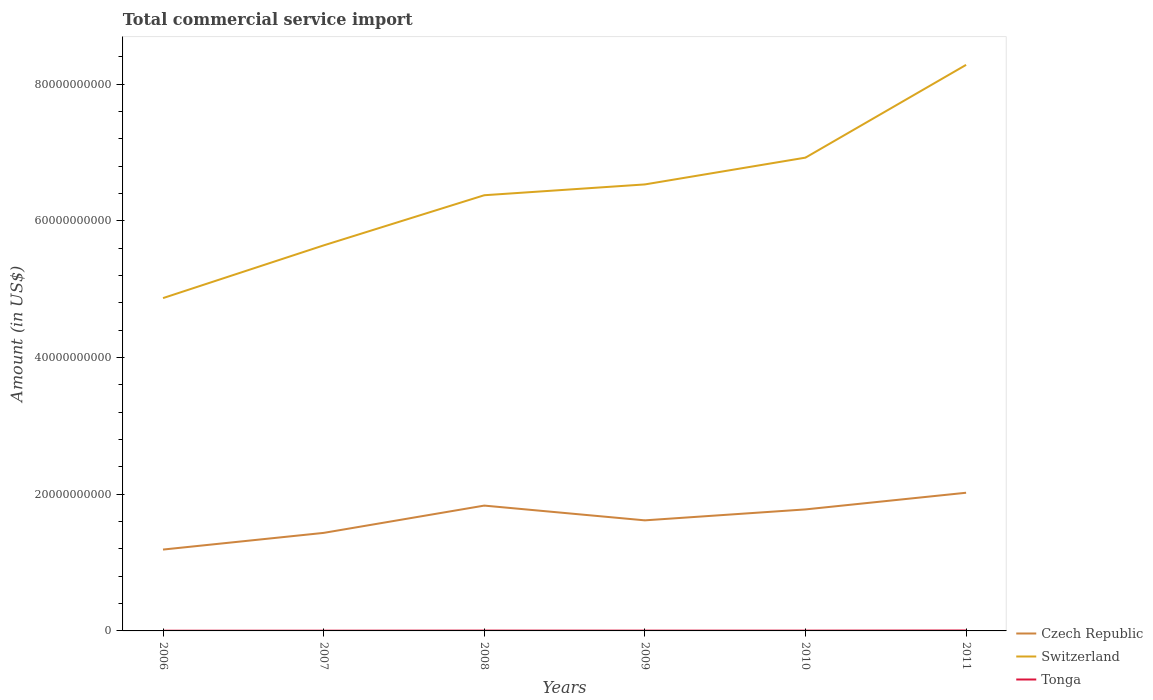Does the line corresponding to Switzerland intersect with the line corresponding to Tonga?
Provide a short and direct response. No. Across all years, what is the maximum total commercial service import in Switzerland?
Give a very brief answer. 4.87e+1. In which year was the total commercial service import in Switzerland maximum?
Provide a short and direct response. 2006. What is the total total commercial service import in Czech Republic in the graph?
Offer a very short reply. -5.87e+09. What is the difference between the highest and the second highest total commercial service import in Switzerland?
Your response must be concise. 3.41e+1. What is the difference between the highest and the lowest total commercial service import in Czech Republic?
Make the answer very short. 3. How many lines are there?
Give a very brief answer. 3. How many years are there in the graph?
Offer a very short reply. 6. What is the difference between two consecutive major ticks on the Y-axis?
Your response must be concise. 2.00e+1. Where does the legend appear in the graph?
Make the answer very short. Bottom right. What is the title of the graph?
Make the answer very short. Total commercial service import. Does "Congo (Republic)" appear as one of the legend labels in the graph?
Offer a terse response. No. What is the label or title of the X-axis?
Make the answer very short. Years. What is the label or title of the Y-axis?
Keep it short and to the point. Amount (in US$). What is the Amount (in US$) in Czech Republic in 2006?
Your answer should be compact. 1.19e+1. What is the Amount (in US$) in Switzerland in 2006?
Your answer should be very brief. 4.87e+1. What is the Amount (in US$) of Tonga in 2006?
Offer a terse response. 2.95e+07. What is the Amount (in US$) of Czech Republic in 2007?
Offer a very short reply. 1.43e+1. What is the Amount (in US$) of Switzerland in 2007?
Ensure brevity in your answer.  5.64e+1. What is the Amount (in US$) in Tonga in 2007?
Your answer should be very brief. 3.50e+07. What is the Amount (in US$) of Czech Republic in 2008?
Your answer should be very brief. 1.83e+1. What is the Amount (in US$) of Switzerland in 2008?
Your answer should be very brief. 6.37e+1. What is the Amount (in US$) in Tonga in 2008?
Provide a short and direct response. 4.82e+07. What is the Amount (in US$) of Czech Republic in 2009?
Keep it short and to the point. 1.62e+1. What is the Amount (in US$) of Switzerland in 2009?
Your answer should be compact. 6.53e+1. What is the Amount (in US$) of Tonga in 2009?
Your answer should be compact. 4.43e+07. What is the Amount (in US$) of Czech Republic in 2010?
Ensure brevity in your answer.  1.78e+1. What is the Amount (in US$) in Switzerland in 2010?
Offer a terse response. 6.92e+1. What is the Amount (in US$) of Tonga in 2010?
Your answer should be compact. 4.24e+07. What is the Amount (in US$) in Czech Republic in 2011?
Give a very brief answer. 2.02e+1. What is the Amount (in US$) in Switzerland in 2011?
Your response must be concise. 8.28e+1. What is the Amount (in US$) in Tonga in 2011?
Give a very brief answer. 6.34e+07. Across all years, what is the maximum Amount (in US$) in Czech Republic?
Provide a short and direct response. 2.02e+1. Across all years, what is the maximum Amount (in US$) in Switzerland?
Provide a short and direct response. 8.28e+1. Across all years, what is the maximum Amount (in US$) in Tonga?
Your answer should be very brief. 6.34e+07. Across all years, what is the minimum Amount (in US$) in Czech Republic?
Make the answer very short. 1.19e+1. Across all years, what is the minimum Amount (in US$) of Switzerland?
Keep it short and to the point. 4.87e+1. Across all years, what is the minimum Amount (in US$) of Tonga?
Offer a very short reply. 2.95e+07. What is the total Amount (in US$) of Czech Republic in the graph?
Your answer should be very brief. 9.87e+1. What is the total Amount (in US$) in Switzerland in the graph?
Keep it short and to the point. 3.86e+11. What is the total Amount (in US$) in Tonga in the graph?
Ensure brevity in your answer.  2.63e+08. What is the difference between the Amount (in US$) in Czech Republic in 2006 and that in 2007?
Offer a very short reply. -2.44e+09. What is the difference between the Amount (in US$) in Switzerland in 2006 and that in 2007?
Make the answer very short. -7.71e+09. What is the difference between the Amount (in US$) of Tonga in 2006 and that in 2007?
Offer a very short reply. -5.45e+06. What is the difference between the Amount (in US$) in Czech Republic in 2006 and that in 2008?
Your response must be concise. -6.43e+09. What is the difference between the Amount (in US$) in Switzerland in 2006 and that in 2008?
Provide a short and direct response. -1.50e+1. What is the difference between the Amount (in US$) in Tonga in 2006 and that in 2008?
Give a very brief answer. -1.87e+07. What is the difference between the Amount (in US$) in Czech Republic in 2006 and that in 2009?
Your answer should be very brief. -4.27e+09. What is the difference between the Amount (in US$) in Switzerland in 2006 and that in 2009?
Give a very brief answer. -1.66e+1. What is the difference between the Amount (in US$) in Tonga in 2006 and that in 2009?
Provide a short and direct response. -1.48e+07. What is the difference between the Amount (in US$) in Czech Republic in 2006 and that in 2010?
Offer a very short reply. -5.87e+09. What is the difference between the Amount (in US$) of Switzerland in 2006 and that in 2010?
Make the answer very short. -2.05e+1. What is the difference between the Amount (in US$) of Tonga in 2006 and that in 2010?
Provide a succinct answer. -1.29e+07. What is the difference between the Amount (in US$) in Czech Republic in 2006 and that in 2011?
Offer a very short reply. -8.31e+09. What is the difference between the Amount (in US$) in Switzerland in 2006 and that in 2011?
Offer a very short reply. -3.41e+1. What is the difference between the Amount (in US$) in Tonga in 2006 and that in 2011?
Offer a very short reply. -3.39e+07. What is the difference between the Amount (in US$) of Czech Republic in 2007 and that in 2008?
Provide a short and direct response. -3.99e+09. What is the difference between the Amount (in US$) of Switzerland in 2007 and that in 2008?
Offer a very short reply. -7.34e+09. What is the difference between the Amount (in US$) in Tonga in 2007 and that in 2008?
Give a very brief answer. -1.33e+07. What is the difference between the Amount (in US$) of Czech Republic in 2007 and that in 2009?
Ensure brevity in your answer.  -1.83e+09. What is the difference between the Amount (in US$) in Switzerland in 2007 and that in 2009?
Your answer should be very brief. -8.92e+09. What is the difference between the Amount (in US$) of Tonga in 2007 and that in 2009?
Keep it short and to the point. -9.30e+06. What is the difference between the Amount (in US$) in Czech Republic in 2007 and that in 2010?
Your response must be concise. -3.43e+09. What is the difference between the Amount (in US$) of Switzerland in 2007 and that in 2010?
Provide a short and direct response. -1.28e+1. What is the difference between the Amount (in US$) of Tonga in 2007 and that in 2010?
Your response must be concise. -7.49e+06. What is the difference between the Amount (in US$) in Czech Republic in 2007 and that in 2011?
Offer a terse response. -5.87e+09. What is the difference between the Amount (in US$) of Switzerland in 2007 and that in 2011?
Keep it short and to the point. -2.64e+1. What is the difference between the Amount (in US$) in Tonga in 2007 and that in 2011?
Provide a succinct answer. -2.85e+07. What is the difference between the Amount (in US$) in Czech Republic in 2008 and that in 2009?
Provide a short and direct response. 2.16e+09. What is the difference between the Amount (in US$) of Switzerland in 2008 and that in 2009?
Your answer should be compact. -1.58e+09. What is the difference between the Amount (in US$) of Tonga in 2008 and that in 2009?
Your answer should be very brief. 3.97e+06. What is the difference between the Amount (in US$) in Czech Republic in 2008 and that in 2010?
Provide a short and direct response. 5.58e+08. What is the difference between the Amount (in US$) of Switzerland in 2008 and that in 2010?
Make the answer very short. -5.50e+09. What is the difference between the Amount (in US$) in Tonga in 2008 and that in 2010?
Your answer should be very brief. 5.78e+06. What is the difference between the Amount (in US$) in Czech Republic in 2008 and that in 2011?
Your response must be concise. -1.88e+09. What is the difference between the Amount (in US$) of Switzerland in 2008 and that in 2011?
Your answer should be compact. -1.91e+1. What is the difference between the Amount (in US$) in Tonga in 2008 and that in 2011?
Your answer should be compact. -1.52e+07. What is the difference between the Amount (in US$) in Czech Republic in 2009 and that in 2010?
Your answer should be compact. -1.60e+09. What is the difference between the Amount (in US$) of Switzerland in 2009 and that in 2010?
Offer a terse response. -3.92e+09. What is the difference between the Amount (in US$) in Tonga in 2009 and that in 2010?
Your response must be concise. 1.81e+06. What is the difference between the Amount (in US$) in Czech Republic in 2009 and that in 2011?
Offer a very short reply. -4.04e+09. What is the difference between the Amount (in US$) in Switzerland in 2009 and that in 2011?
Provide a short and direct response. -1.75e+1. What is the difference between the Amount (in US$) in Tonga in 2009 and that in 2011?
Your answer should be very brief. -1.92e+07. What is the difference between the Amount (in US$) in Czech Republic in 2010 and that in 2011?
Your answer should be compact. -2.44e+09. What is the difference between the Amount (in US$) of Switzerland in 2010 and that in 2011?
Your answer should be very brief. -1.36e+1. What is the difference between the Amount (in US$) in Tonga in 2010 and that in 2011?
Provide a succinct answer. -2.10e+07. What is the difference between the Amount (in US$) in Czech Republic in 2006 and the Amount (in US$) in Switzerland in 2007?
Give a very brief answer. -4.45e+1. What is the difference between the Amount (in US$) of Czech Republic in 2006 and the Amount (in US$) of Tonga in 2007?
Offer a terse response. 1.19e+1. What is the difference between the Amount (in US$) in Switzerland in 2006 and the Amount (in US$) in Tonga in 2007?
Keep it short and to the point. 4.87e+1. What is the difference between the Amount (in US$) in Czech Republic in 2006 and the Amount (in US$) in Switzerland in 2008?
Provide a short and direct response. -5.18e+1. What is the difference between the Amount (in US$) of Czech Republic in 2006 and the Amount (in US$) of Tonga in 2008?
Your response must be concise. 1.19e+1. What is the difference between the Amount (in US$) in Switzerland in 2006 and the Amount (in US$) in Tonga in 2008?
Your answer should be very brief. 4.86e+1. What is the difference between the Amount (in US$) in Czech Republic in 2006 and the Amount (in US$) in Switzerland in 2009?
Your answer should be very brief. -5.34e+1. What is the difference between the Amount (in US$) in Czech Republic in 2006 and the Amount (in US$) in Tonga in 2009?
Provide a short and direct response. 1.19e+1. What is the difference between the Amount (in US$) of Switzerland in 2006 and the Amount (in US$) of Tonga in 2009?
Your answer should be compact. 4.86e+1. What is the difference between the Amount (in US$) in Czech Republic in 2006 and the Amount (in US$) in Switzerland in 2010?
Your answer should be very brief. -5.73e+1. What is the difference between the Amount (in US$) of Czech Republic in 2006 and the Amount (in US$) of Tonga in 2010?
Your answer should be very brief. 1.19e+1. What is the difference between the Amount (in US$) in Switzerland in 2006 and the Amount (in US$) in Tonga in 2010?
Provide a succinct answer. 4.86e+1. What is the difference between the Amount (in US$) in Czech Republic in 2006 and the Amount (in US$) in Switzerland in 2011?
Keep it short and to the point. -7.09e+1. What is the difference between the Amount (in US$) in Czech Republic in 2006 and the Amount (in US$) in Tonga in 2011?
Your answer should be compact. 1.18e+1. What is the difference between the Amount (in US$) in Switzerland in 2006 and the Amount (in US$) in Tonga in 2011?
Provide a succinct answer. 4.86e+1. What is the difference between the Amount (in US$) in Czech Republic in 2007 and the Amount (in US$) in Switzerland in 2008?
Your answer should be compact. -4.94e+1. What is the difference between the Amount (in US$) in Czech Republic in 2007 and the Amount (in US$) in Tonga in 2008?
Offer a very short reply. 1.43e+1. What is the difference between the Amount (in US$) of Switzerland in 2007 and the Amount (in US$) of Tonga in 2008?
Give a very brief answer. 5.63e+1. What is the difference between the Amount (in US$) in Czech Republic in 2007 and the Amount (in US$) in Switzerland in 2009?
Make the answer very short. -5.10e+1. What is the difference between the Amount (in US$) in Czech Republic in 2007 and the Amount (in US$) in Tonga in 2009?
Provide a succinct answer. 1.43e+1. What is the difference between the Amount (in US$) in Switzerland in 2007 and the Amount (in US$) in Tonga in 2009?
Provide a short and direct response. 5.64e+1. What is the difference between the Amount (in US$) of Czech Republic in 2007 and the Amount (in US$) of Switzerland in 2010?
Your answer should be compact. -5.49e+1. What is the difference between the Amount (in US$) of Czech Republic in 2007 and the Amount (in US$) of Tonga in 2010?
Your answer should be very brief. 1.43e+1. What is the difference between the Amount (in US$) of Switzerland in 2007 and the Amount (in US$) of Tonga in 2010?
Offer a terse response. 5.64e+1. What is the difference between the Amount (in US$) of Czech Republic in 2007 and the Amount (in US$) of Switzerland in 2011?
Give a very brief answer. -6.85e+1. What is the difference between the Amount (in US$) in Czech Republic in 2007 and the Amount (in US$) in Tonga in 2011?
Provide a short and direct response. 1.43e+1. What is the difference between the Amount (in US$) in Switzerland in 2007 and the Amount (in US$) in Tonga in 2011?
Give a very brief answer. 5.63e+1. What is the difference between the Amount (in US$) in Czech Republic in 2008 and the Amount (in US$) in Switzerland in 2009?
Make the answer very short. -4.70e+1. What is the difference between the Amount (in US$) in Czech Republic in 2008 and the Amount (in US$) in Tonga in 2009?
Your response must be concise. 1.83e+1. What is the difference between the Amount (in US$) in Switzerland in 2008 and the Amount (in US$) in Tonga in 2009?
Provide a succinct answer. 6.37e+1. What is the difference between the Amount (in US$) of Czech Republic in 2008 and the Amount (in US$) of Switzerland in 2010?
Ensure brevity in your answer.  -5.09e+1. What is the difference between the Amount (in US$) in Czech Republic in 2008 and the Amount (in US$) in Tonga in 2010?
Your response must be concise. 1.83e+1. What is the difference between the Amount (in US$) in Switzerland in 2008 and the Amount (in US$) in Tonga in 2010?
Offer a very short reply. 6.37e+1. What is the difference between the Amount (in US$) in Czech Republic in 2008 and the Amount (in US$) in Switzerland in 2011?
Your answer should be compact. -6.45e+1. What is the difference between the Amount (in US$) in Czech Republic in 2008 and the Amount (in US$) in Tonga in 2011?
Your answer should be very brief. 1.83e+1. What is the difference between the Amount (in US$) of Switzerland in 2008 and the Amount (in US$) of Tonga in 2011?
Ensure brevity in your answer.  6.37e+1. What is the difference between the Amount (in US$) of Czech Republic in 2009 and the Amount (in US$) of Switzerland in 2010?
Your answer should be compact. -5.31e+1. What is the difference between the Amount (in US$) of Czech Republic in 2009 and the Amount (in US$) of Tonga in 2010?
Give a very brief answer. 1.61e+1. What is the difference between the Amount (in US$) of Switzerland in 2009 and the Amount (in US$) of Tonga in 2010?
Make the answer very short. 6.53e+1. What is the difference between the Amount (in US$) of Czech Republic in 2009 and the Amount (in US$) of Switzerland in 2011?
Keep it short and to the point. -6.66e+1. What is the difference between the Amount (in US$) of Czech Republic in 2009 and the Amount (in US$) of Tonga in 2011?
Your response must be concise. 1.61e+1. What is the difference between the Amount (in US$) of Switzerland in 2009 and the Amount (in US$) of Tonga in 2011?
Keep it short and to the point. 6.53e+1. What is the difference between the Amount (in US$) in Czech Republic in 2010 and the Amount (in US$) in Switzerland in 2011?
Give a very brief answer. -6.50e+1. What is the difference between the Amount (in US$) in Czech Republic in 2010 and the Amount (in US$) in Tonga in 2011?
Ensure brevity in your answer.  1.77e+1. What is the difference between the Amount (in US$) in Switzerland in 2010 and the Amount (in US$) in Tonga in 2011?
Your answer should be very brief. 6.92e+1. What is the average Amount (in US$) in Czech Republic per year?
Keep it short and to the point. 1.65e+1. What is the average Amount (in US$) in Switzerland per year?
Your response must be concise. 6.44e+1. What is the average Amount (in US$) of Tonga per year?
Give a very brief answer. 4.38e+07. In the year 2006, what is the difference between the Amount (in US$) of Czech Republic and Amount (in US$) of Switzerland?
Your response must be concise. -3.68e+1. In the year 2006, what is the difference between the Amount (in US$) of Czech Republic and Amount (in US$) of Tonga?
Make the answer very short. 1.19e+1. In the year 2006, what is the difference between the Amount (in US$) in Switzerland and Amount (in US$) in Tonga?
Make the answer very short. 4.87e+1. In the year 2007, what is the difference between the Amount (in US$) of Czech Republic and Amount (in US$) of Switzerland?
Keep it short and to the point. -4.21e+1. In the year 2007, what is the difference between the Amount (in US$) in Czech Republic and Amount (in US$) in Tonga?
Your answer should be compact. 1.43e+1. In the year 2007, what is the difference between the Amount (in US$) in Switzerland and Amount (in US$) in Tonga?
Make the answer very short. 5.64e+1. In the year 2008, what is the difference between the Amount (in US$) of Czech Republic and Amount (in US$) of Switzerland?
Offer a very short reply. -4.54e+1. In the year 2008, what is the difference between the Amount (in US$) in Czech Republic and Amount (in US$) in Tonga?
Keep it short and to the point. 1.83e+1. In the year 2008, what is the difference between the Amount (in US$) of Switzerland and Amount (in US$) of Tonga?
Ensure brevity in your answer.  6.37e+1. In the year 2009, what is the difference between the Amount (in US$) of Czech Republic and Amount (in US$) of Switzerland?
Your response must be concise. -4.91e+1. In the year 2009, what is the difference between the Amount (in US$) of Czech Republic and Amount (in US$) of Tonga?
Provide a succinct answer. 1.61e+1. In the year 2009, what is the difference between the Amount (in US$) in Switzerland and Amount (in US$) in Tonga?
Your answer should be very brief. 6.53e+1. In the year 2010, what is the difference between the Amount (in US$) in Czech Republic and Amount (in US$) in Switzerland?
Offer a terse response. -5.15e+1. In the year 2010, what is the difference between the Amount (in US$) in Czech Republic and Amount (in US$) in Tonga?
Provide a succinct answer. 1.77e+1. In the year 2010, what is the difference between the Amount (in US$) of Switzerland and Amount (in US$) of Tonga?
Offer a terse response. 6.92e+1. In the year 2011, what is the difference between the Amount (in US$) of Czech Republic and Amount (in US$) of Switzerland?
Offer a very short reply. -6.26e+1. In the year 2011, what is the difference between the Amount (in US$) of Czech Republic and Amount (in US$) of Tonga?
Offer a terse response. 2.01e+1. In the year 2011, what is the difference between the Amount (in US$) in Switzerland and Amount (in US$) in Tonga?
Your answer should be very brief. 8.27e+1. What is the ratio of the Amount (in US$) in Czech Republic in 2006 to that in 2007?
Keep it short and to the point. 0.83. What is the ratio of the Amount (in US$) of Switzerland in 2006 to that in 2007?
Offer a terse response. 0.86. What is the ratio of the Amount (in US$) of Tonga in 2006 to that in 2007?
Make the answer very short. 0.84. What is the ratio of the Amount (in US$) in Czech Republic in 2006 to that in 2008?
Offer a terse response. 0.65. What is the ratio of the Amount (in US$) of Switzerland in 2006 to that in 2008?
Your answer should be compact. 0.76. What is the ratio of the Amount (in US$) in Tonga in 2006 to that in 2008?
Your answer should be compact. 0.61. What is the ratio of the Amount (in US$) in Czech Republic in 2006 to that in 2009?
Provide a succinct answer. 0.74. What is the ratio of the Amount (in US$) of Switzerland in 2006 to that in 2009?
Offer a very short reply. 0.75. What is the ratio of the Amount (in US$) of Tonga in 2006 to that in 2009?
Your response must be concise. 0.67. What is the ratio of the Amount (in US$) of Czech Republic in 2006 to that in 2010?
Your response must be concise. 0.67. What is the ratio of the Amount (in US$) in Switzerland in 2006 to that in 2010?
Your response must be concise. 0.7. What is the ratio of the Amount (in US$) of Tonga in 2006 to that in 2010?
Offer a terse response. 0.69. What is the ratio of the Amount (in US$) of Czech Republic in 2006 to that in 2011?
Make the answer very short. 0.59. What is the ratio of the Amount (in US$) in Switzerland in 2006 to that in 2011?
Your answer should be compact. 0.59. What is the ratio of the Amount (in US$) of Tonga in 2006 to that in 2011?
Provide a short and direct response. 0.47. What is the ratio of the Amount (in US$) in Czech Republic in 2007 to that in 2008?
Provide a short and direct response. 0.78. What is the ratio of the Amount (in US$) of Switzerland in 2007 to that in 2008?
Provide a short and direct response. 0.88. What is the ratio of the Amount (in US$) of Tonga in 2007 to that in 2008?
Offer a terse response. 0.72. What is the ratio of the Amount (in US$) of Czech Republic in 2007 to that in 2009?
Make the answer very short. 0.89. What is the ratio of the Amount (in US$) of Switzerland in 2007 to that in 2009?
Give a very brief answer. 0.86. What is the ratio of the Amount (in US$) in Tonga in 2007 to that in 2009?
Ensure brevity in your answer.  0.79. What is the ratio of the Amount (in US$) of Czech Republic in 2007 to that in 2010?
Offer a very short reply. 0.81. What is the ratio of the Amount (in US$) of Switzerland in 2007 to that in 2010?
Ensure brevity in your answer.  0.81. What is the ratio of the Amount (in US$) in Tonga in 2007 to that in 2010?
Make the answer very short. 0.82. What is the ratio of the Amount (in US$) of Czech Republic in 2007 to that in 2011?
Offer a very short reply. 0.71. What is the ratio of the Amount (in US$) in Switzerland in 2007 to that in 2011?
Give a very brief answer. 0.68. What is the ratio of the Amount (in US$) of Tonga in 2007 to that in 2011?
Provide a short and direct response. 0.55. What is the ratio of the Amount (in US$) in Czech Republic in 2008 to that in 2009?
Offer a very short reply. 1.13. What is the ratio of the Amount (in US$) of Switzerland in 2008 to that in 2009?
Make the answer very short. 0.98. What is the ratio of the Amount (in US$) of Tonga in 2008 to that in 2009?
Provide a short and direct response. 1.09. What is the ratio of the Amount (in US$) in Czech Republic in 2008 to that in 2010?
Your answer should be very brief. 1.03. What is the ratio of the Amount (in US$) in Switzerland in 2008 to that in 2010?
Provide a short and direct response. 0.92. What is the ratio of the Amount (in US$) of Tonga in 2008 to that in 2010?
Provide a short and direct response. 1.14. What is the ratio of the Amount (in US$) of Czech Republic in 2008 to that in 2011?
Your answer should be compact. 0.91. What is the ratio of the Amount (in US$) in Switzerland in 2008 to that in 2011?
Your answer should be compact. 0.77. What is the ratio of the Amount (in US$) of Tonga in 2008 to that in 2011?
Give a very brief answer. 0.76. What is the ratio of the Amount (in US$) in Czech Republic in 2009 to that in 2010?
Your answer should be very brief. 0.91. What is the ratio of the Amount (in US$) of Switzerland in 2009 to that in 2010?
Your answer should be very brief. 0.94. What is the ratio of the Amount (in US$) in Tonga in 2009 to that in 2010?
Your answer should be compact. 1.04. What is the ratio of the Amount (in US$) in Czech Republic in 2009 to that in 2011?
Provide a short and direct response. 0.8. What is the ratio of the Amount (in US$) of Switzerland in 2009 to that in 2011?
Provide a short and direct response. 0.79. What is the ratio of the Amount (in US$) in Tonga in 2009 to that in 2011?
Offer a terse response. 0.7. What is the ratio of the Amount (in US$) in Czech Republic in 2010 to that in 2011?
Ensure brevity in your answer.  0.88. What is the ratio of the Amount (in US$) of Switzerland in 2010 to that in 2011?
Provide a short and direct response. 0.84. What is the ratio of the Amount (in US$) in Tonga in 2010 to that in 2011?
Keep it short and to the point. 0.67. What is the difference between the highest and the second highest Amount (in US$) in Czech Republic?
Ensure brevity in your answer.  1.88e+09. What is the difference between the highest and the second highest Amount (in US$) in Switzerland?
Offer a terse response. 1.36e+1. What is the difference between the highest and the second highest Amount (in US$) of Tonga?
Give a very brief answer. 1.52e+07. What is the difference between the highest and the lowest Amount (in US$) of Czech Republic?
Offer a very short reply. 8.31e+09. What is the difference between the highest and the lowest Amount (in US$) of Switzerland?
Provide a short and direct response. 3.41e+1. What is the difference between the highest and the lowest Amount (in US$) in Tonga?
Provide a succinct answer. 3.39e+07. 